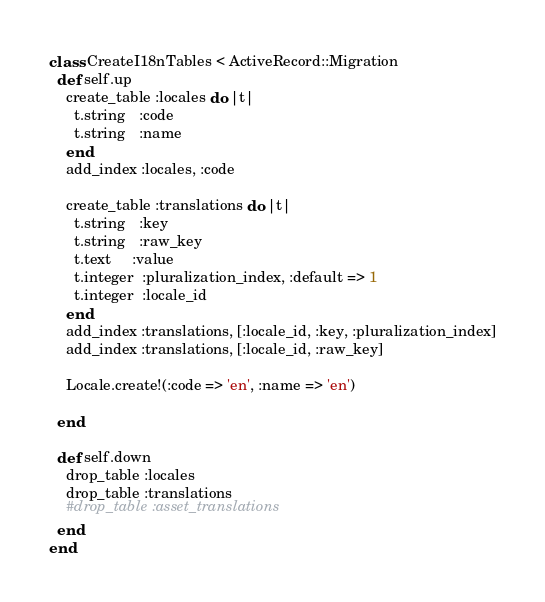<code> <loc_0><loc_0><loc_500><loc_500><_Ruby_>class CreateI18nTables < ActiveRecord::Migration
  def self.up
    create_table :locales do |t|
      t.string   :code
      t.string   :name
    end
    add_index :locales, :code

    create_table :translations do |t|
      t.string   :key
      t.string   :raw_key
      t.text     :value
      t.integer  :pluralization_index, :default => 1
      t.integer  :locale_id
    end
    add_index :translations, [:locale_id, :key, :pluralization_index]
    add_index :translations, [:locale_id, :raw_key]

    Locale.create!(:code => 'en', :name => 'en')

  end

  def self.down
    drop_table :locales
    drop_table :translations
    #drop_table :asset_translations
  end
end
</code> 